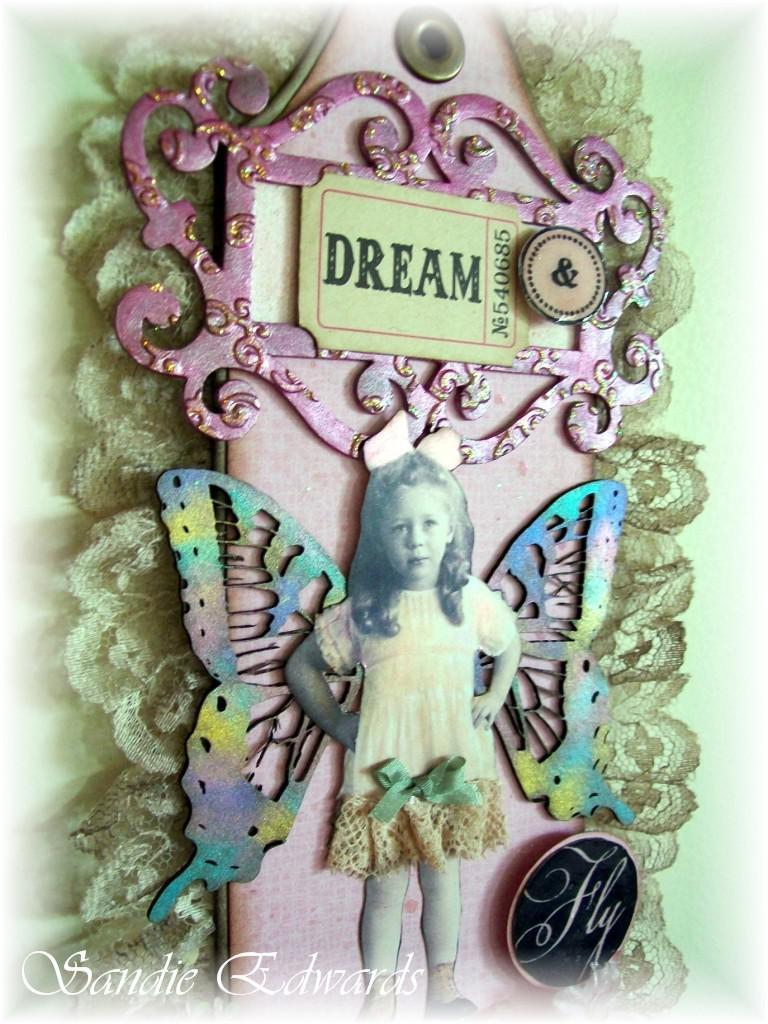<image>
Present a compact description of the photo's key features. "Dream" is printed onto a ticket as part of this art piece. 